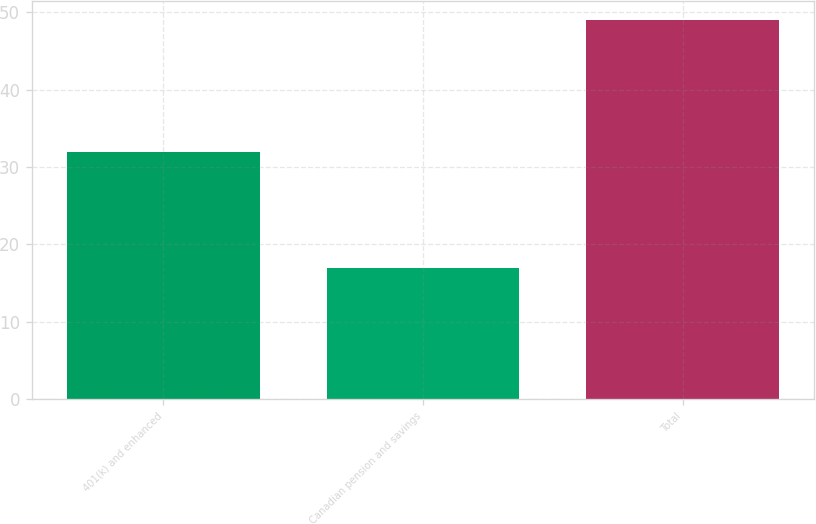Convert chart to OTSL. <chart><loc_0><loc_0><loc_500><loc_500><bar_chart><fcel>401(k) and enhanced<fcel>Canadian pension and savings<fcel>Total<nl><fcel>32<fcel>17<fcel>49<nl></chart> 